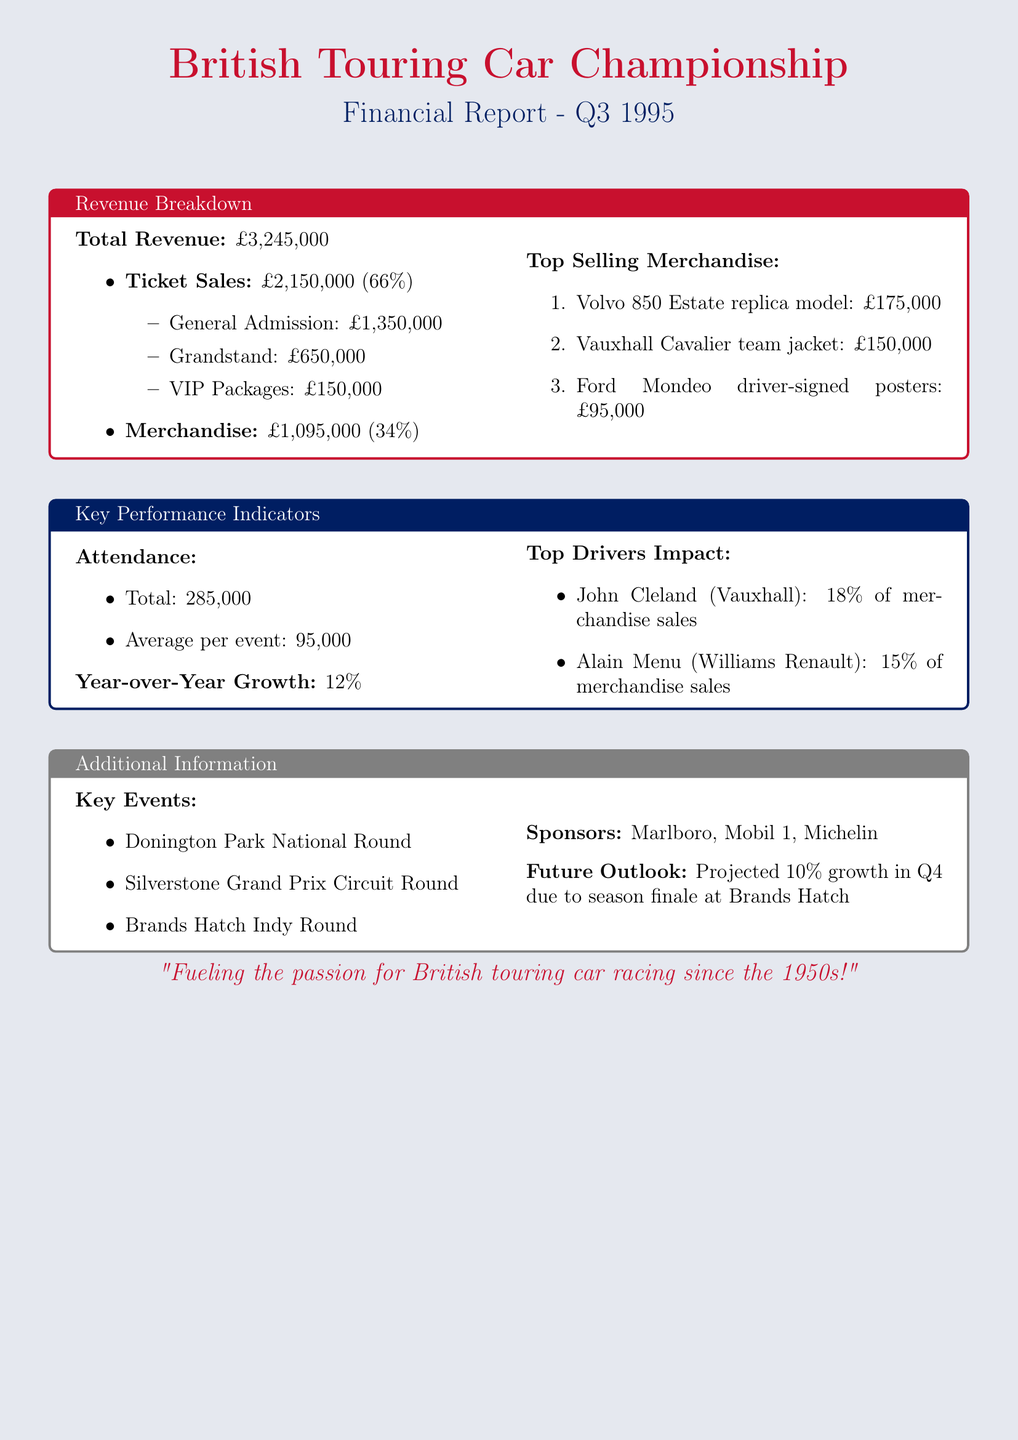what is the total revenue? The total revenue is clearly stated at the beginning of the revenue breakdown section.
Answer: £3,245,000 how much revenue was generated from ticket sales? Ticket sales revenue is listed as a separate item in the revenue breakdown, along with the exact amount.
Answer: £2,150,000 what was the year-over-year growth percentage in ticket sales? The year-over-year growth is provided specifically for ticket sales, indicating the performance compared to the previous year.
Answer: 12% which item generated the highest merchandise revenue? The top selling items are listed with their revenues, indicating which had the highest sales figures.
Answer: Volvo 850 Estate replica model how many key events took place in Q3 1995? The document lists the key events sequentially, allowing one to count how many were mentioned.
Answer: 3 who were the top contributing drivers for merchandise sales? The document enumerates the drivers and their respective contributions, making it clear who impacted sales the most.
Answer: John Cleland, Alain Menu what is the total attendance for Q3 1995? The total attendance figure is provided in the attendance section of the report.
Answer: 285,000 what is the projected growth for Q4? The future outlook section mentions the projected growth figure for the next quarter based on expectations related to events.
Answer: 10% 